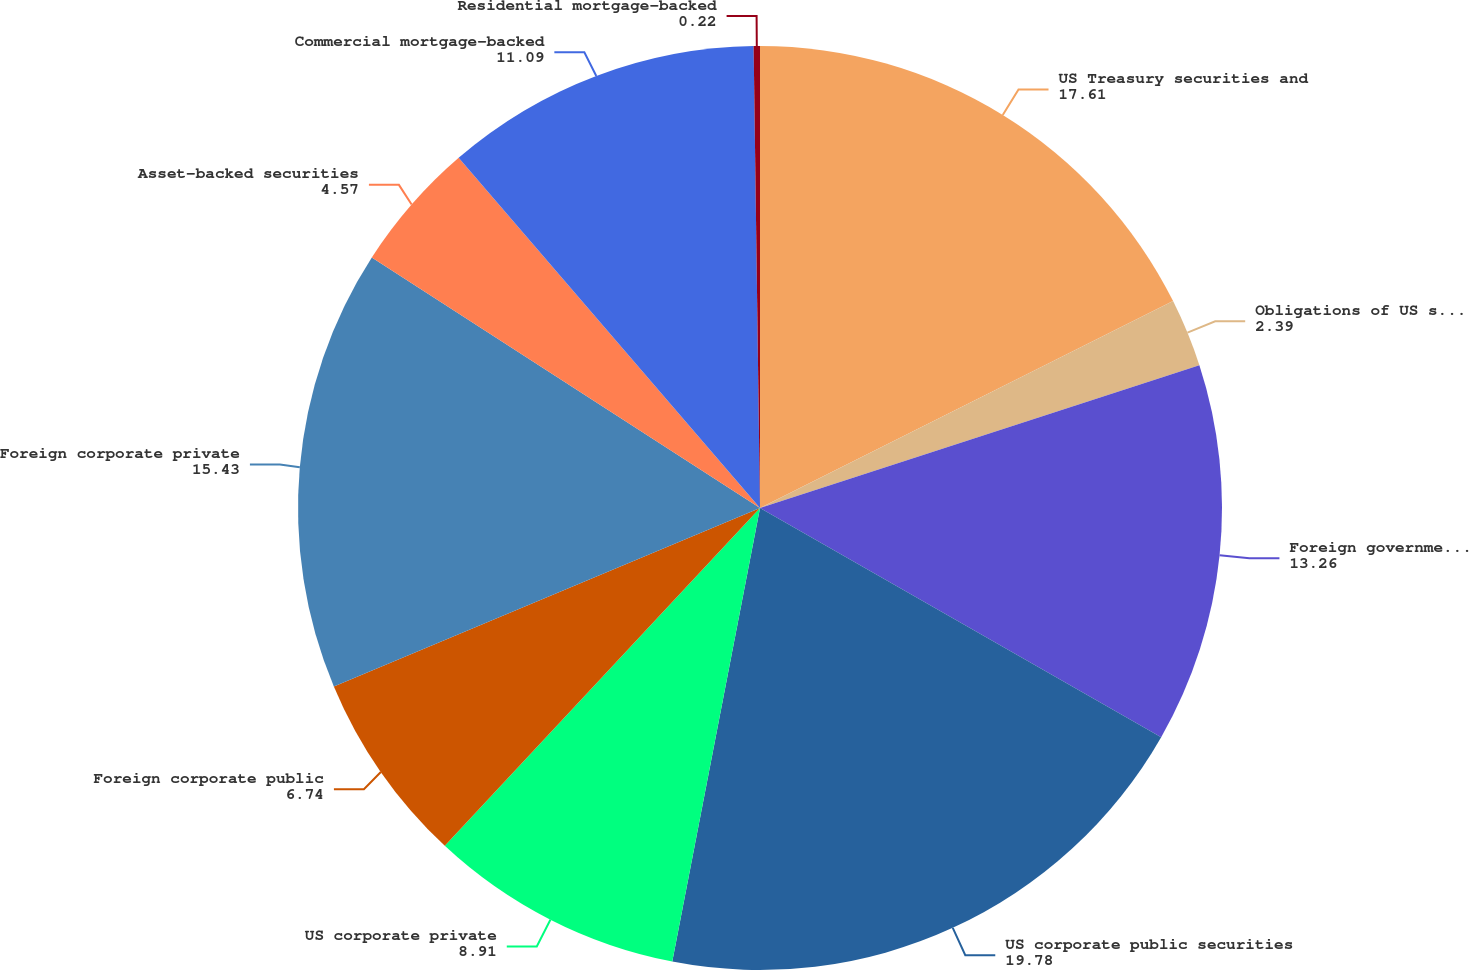<chart> <loc_0><loc_0><loc_500><loc_500><pie_chart><fcel>US Treasury securities and<fcel>Obligations of US states and<fcel>Foreign government bonds<fcel>US corporate public securities<fcel>US corporate private<fcel>Foreign corporate public<fcel>Foreign corporate private<fcel>Asset-backed securities<fcel>Commercial mortgage-backed<fcel>Residential mortgage-backed<nl><fcel>17.61%<fcel>2.39%<fcel>13.26%<fcel>19.78%<fcel>8.91%<fcel>6.74%<fcel>15.43%<fcel>4.57%<fcel>11.09%<fcel>0.22%<nl></chart> 